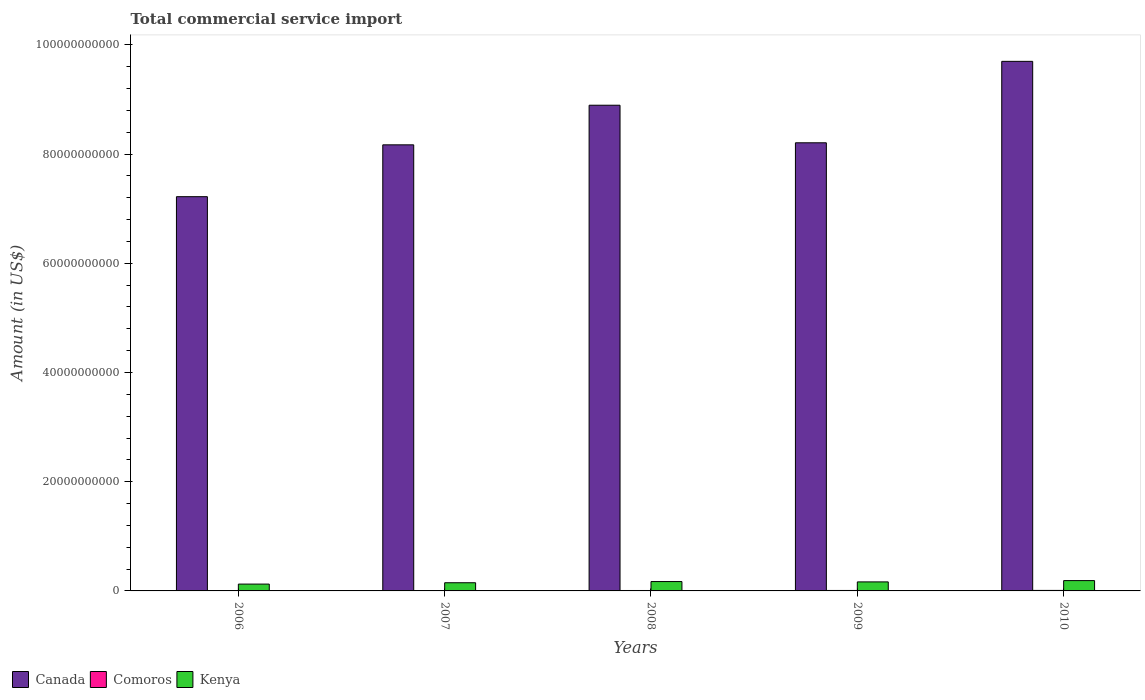How many different coloured bars are there?
Offer a terse response. 3. What is the label of the 3rd group of bars from the left?
Your answer should be very brief. 2008. In how many cases, is the number of bars for a given year not equal to the number of legend labels?
Provide a short and direct response. 0. What is the total commercial service import in Canada in 2008?
Your answer should be compact. 8.90e+1. Across all years, what is the maximum total commercial service import in Comoros?
Make the answer very short. 9.30e+07. Across all years, what is the minimum total commercial service import in Kenya?
Make the answer very short. 1.25e+09. What is the total total commercial service import in Comoros in the graph?
Your answer should be very brief. 3.70e+08. What is the difference between the total commercial service import in Canada in 2006 and that in 2008?
Your response must be concise. -1.67e+1. What is the difference between the total commercial service import in Comoros in 2010 and the total commercial service import in Canada in 2006?
Give a very brief answer. -7.21e+1. What is the average total commercial service import in Kenya per year?
Keep it short and to the point. 1.60e+09. In the year 2007, what is the difference between the total commercial service import in Canada and total commercial service import in Comoros?
Your answer should be very brief. 8.16e+1. In how many years, is the total commercial service import in Kenya greater than 36000000000 US$?
Provide a short and direct response. 0. What is the ratio of the total commercial service import in Comoros in 2007 to that in 2008?
Your answer should be compact. 0.81. Is the total commercial service import in Canada in 2006 less than that in 2010?
Provide a succinct answer. Yes. What is the difference between the highest and the second highest total commercial service import in Canada?
Provide a succinct answer. 8.03e+09. What is the difference between the highest and the lowest total commercial service import in Kenya?
Your answer should be compact. 6.38e+08. In how many years, is the total commercial service import in Kenya greater than the average total commercial service import in Kenya taken over all years?
Give a very brief answer. 3. What does the 3rd bar from the left in 2010 represents?
Offer a terse response. Kenya. What does the 2nd bar from the right in 2009 represents?
Ensure brevity in your answer.  Comoros. Is it the case that in every year, the sum of the total commercial service import in Kenya and total commercial service import in Canada is greater than the total commercial service import in Comoros?
Give a very brief answer. Yes. Are all the bars in the graph horizontal?
Your answer should be very brief. No. What is the difference between two consecutive major ticks on the Y-axis?
Provide a short and direct response. 2.00e+1. Are the values on the major ticks of Y-axis written in scientific E-notation?
Keep it short and to the point. No. Does the graph contain any zero values?
Your response must be concise. No. Does the graph contain grids?
Offer a very short reply. No. How are the legend labels stacked?
Make the answer very short. Horizontal. What is the title of the graph?
Provide a short and direct response. Total commercial service import. Does "Lebanon" appear as one of the legend labels in the graph?
Give a very brief answer. No. What is the label or title of the X-axis?
Your response must be concise. Years. What is the label or title of the Y-axis?
Provide a short and direct response. Amount (in US$). What is the Amount (in US$) of Canada in 2006?
Your response must be concise. 7.22e+1. What is the Amount (in US$) in Comoros in 2006?
Provide a short and direct response. 5.40e+07. What is the Amount (in US$) in Kenya in 2006?
Give a very brief answer. 1.25e+09. What is the Amount (in US$) of Canada in 2007?
Your response must be concise. 8.17e+1. What is the Amount (in US$) in Comoros in 2007?
Give a very brief answer. 6.23e+07. What is the Amount (in US$) in Kenya in 2007?
Give a very brief answer. 1.50e+09. What is the Amount (in US$) in Canada in 2008?
Ensure brevity in your answer.  8.90e+1. What is the Amount (in US$) of Comoros in 2008?
Give a very brief answer. 7.72e+07. What is the Amount (in US$) of Kenya in 2008?
Offer a very short reply. 1.72e+09. What is the Amount (in US$) of Canada in 2009?
Your answer should be compact. 8.21e+1. What is the Amount (in US$) of Comoros in 2009?
Ensure brevity in your answer.  8.35e+07. What is the Amount (in US$) of Kenya in 2009?
Give a very brief answer. 1.65e+09. What is the Amount (in US$) of Canada in 2010?
Make the answer very short. 9.70e+1. What is the Amount (in US$) of Comoros in 2010?
Make the answer very short. 9.30e+07. What is the Amount (in US$) of Kenya in 2010?
Make the answer very short. 1.89e+09. Across all years, what is the maximum Amount (in US$) of Canada?
Offer a very short reply. 9.70e+1. Across all years, what is the maximum Amount (in US$) in Comoros?
Make the answer very short. 9.30e+07. Across all years, what is the maximum Amount (in US$) of Kenya?
Provide a succinct answer. 1.89e+09. Across all years, what is the minimum Amount (in US$) in Canada?
Your answer should be compact. 7.22e+1. Across all years, what is the minimum Amount (in US$) of Comoros?
Your answer should be compact. 5.40e+07. Across all years, what is the minimum Amount (in US$) of Kenya?
Provide a short and direct response. 1.25e+09. What is the total Amount (in US$) of Canada in the graph?
Offer a terse response. 4.22e+11. What is the total Amount (in US$) of Comoros in the graph?
Your answer should be very brief. 3.70e+08. What is the total Amount (in US$) in Kenya in the graph?
Provide a succinct answer. 8.01e+09. What is the difference between the Amount (in US$) in Canada in 2006 and that in 2007?
Your response must be concise. -9.50e+09. What is the difference between the Amount (in US$) in Comoros in 2006 and that in 2007?
Your response must be concise. -8.35e+06. What is the difference between the Amount (in US$) of Kenya in 2006 and that in 2007?
Give a very brief answer. -2.47e+08. What is the difference between the Amount (in US$) in Canada in 2006 and that in 2008?
Keep it short and to the point. -1.67e+1. What is the difference between the Amount (in US$) of Comoros in 2006 and that in 2008?
Provide a short and direct response. -2.32e+07. What is the difference between the Amount (in US$) of Kenya in 2006 and that in 2008?
Provide a short and direct response. -4.64e+08. What is the difference between the Amount (in US$) in Canada in 2006 and that in 2009?
Ensure brevity in your answer.  -9.87e+09. What is the difference between the Amount (in US$) of Comoros in 2006 and that in 2009?
Offer a very short reply. -2.95e+07. What is the difference between the Amount (in US$) of Kenya in 2006 and that in 2009?
Your answer should be very brief. -4.00e+08. What is the difference between the Amount (in US$) in Canada in 2006 and that in 2010?
Ensure brevity in your answer.  -2.48e+1. What is the difference between the Amount (in US$) in Comoros in 2006 and that in 2010?
Your response must be concise. -3.90e+07. What is the difference between the Amount (in US$) in Kenya in 2006 and that in 2010?
Your answer should be compact. -6.38e+08. What is the difference between the Amount (in US$) in Canada in 2007 and that in 2008?
Make the answer very short. -7.25e+09. What is the difference between the Amount (in US$) of Comoros in 2007 and that in 2008?
Your answer should be compact. -1.49e+07. What is the difference between the Amount (in US$) in Kenya in 2007 and that in 2008?
Offer a very short reply. -2.18e+08. What is the difference between the Amount (in US$) in Canada in 2007 and that in 2009?
Keep it short and to the point. -3.74e+08. What is the difference between the Amount (in US$) of Comoros in 2007 and that in 2009?
Provide a short and direct response. -2.12e+07. What is the difference between the Amount (in US$) in Kenya in 2007 and that in 2009?
Your answer should be compact. -1.54e+08. What is the difference between the Amount (in US$) of Canada in 2007 and that in 2010?
Your answer should be very brief. -1.53e+1. What is the difference between the Amount (in US$) in Comoros in 2007 and that in 2010?
Offer a very short reply. -3.06e+07. What is the difference between the Amount (in US$) of Kenya in 2007 and that in 2010?
Offer a very short reply. -3.91e+08. What is the difference between the Amount (in US$) in Canada in 2008 and that in 2009?
Make the answer very short. 6.88e+09. What is the difference between the Amount (in US$) of Comoros in 2008 and that in 2009?
Provide a succinct answer. -6.31e+06. What is the difference between the Amount (in US$) in Kenya in 2008 and that in 2009?
Your answer should be very brief. 6.37e+07. What is the difference between the Amount (in US$) in Canada in 2008 and that in 2010?
Keep it short and to the point. -8.03e+09. What is the difference between the Amount (in US$) in Comoros in 2008 and that in 2010?
Your answer should be very brief. -1.58e+07. What is the difference between the Amount (in US$) of Kenya in 2008 and that in 2010?
Keep it short and to the point. -1.74e+08. What is the difference between the Amount (in US$) of Canada in 2009 and that in 2010?
Your answer should be compact. -1.49e+1. What is the difference between the Amount (in US$) of Comoros in 2009 and that in 2010?
Provide a succinct answer. -9.48e+06. What is the difference between the Amount (in US$) of Kenya in 2009 and that in 2010?
Offer a terse response. -2.37e+08. What is the difference between the Amount (in US$) in Canada in 2006 and the Amount (in US$) in Comoros in 2007?
Offer a terse response. 7.21e+1. What is the difference between the Amount (in US$) in Canada in 2006 and the Amount (in US$) in Kenya in 2007?
Offer a very short reply. 7.07e+1. What is the difference between the Amount (in US$) of Comoros in 2006 and the Amount (in US$) of Kenya in 2007?
Your response must be concise. -1.44e+09. What is the difference between the Amount (in US$) in Canada in 2006 and the Amount (in US$) in Comoros in 2008?
Provide a short and direct response. 7.21e+1. What is the difference between the Amount (in US$) of Canada in 2006 and the Amount (in US$) of Kenya in 2008?
Provide a succinct answer. 7.05e+1. What is the difference between the Amount (in US$) of Comoros in 2006 and the Amount (in US$) of Kenya in 2008?
Ensure brevity in your answer.  -1.66e+09. What is the difference between the Amount (in US$) of Canada in 2006 and the Amount (in US$) of Comoros in 2009?
Ensure brevity in your answer.  7.21e+1. What is the difference between the Amount (in US$) of Canada in 2006 and the Amount (in US$) of Kenya in 2009?
Provide a short and direct response. 7.05e+1. What is the difference between the Amount (in US$) in Comoros in 2006 and the Amount (in US$) in Kenya in 2009?
Your answer should be very brief. -1.60e+09. What is the difference between the Amount (in US$) in Canada in 2006 and the Amount (in US$) in Comoros in 2010?
Provide a succinct answer. 7.21e+1. What is the difference between the Amount (in US$) in Canada in 2006 and the Amount (in US$) in Kenya in 2010?
Give a very brief answer. 7.03e+1. What is the difference between the Amount (in US$) in Comoros in 2006 and the Amount (in US$) in Kenya in 2010?
Your answer should be compact. -1.84e+09. What is the difference between the Amount (in US$) of Canada in 2007 and the Amount (in US$) of Comoros in 2008?
Make the answer very short. 8.16e+1. What is the difference between the Amount (in US$) in Canada in 2007 and the Amount (in US$) in Kenya in 2008?
Offer a very short reply. 8.00e+1. What is the difference between the Amount (in US$) in Comoros in 2007 and the Amount (in US$) in Kenya in 2008?
Ensure brevity in your answer.  -1.65e+09. What is the difference between the Amount (in US$) in Canada in 2007 and the Amount (in US$) in Comoros in 2009?
Offer a very short reply. 8.16e+1. What is the difference between the Amount (in US$) in Canada in 2007 and the Amount (in US$) in Kenya in 2009?
Your response must be concise. 8.00e+1. What is the difference between the Amount (in US$) of Comoros in 2007 and the Amount (in US$) of Kenya in 2009?
Offer a very short reply. -1.59e+09. What is the difference between the Amount (in US$) of Canada in 2007 and the Amount (in US$) of Comoros in 2010?
Offer a very short reply. 8.16e+1. What is the difference between the Amount (in US$) in Canada in 2007 and the Amount (in US$) in Kenya in 2010?
Offer a terse response. 7.98e+1. What is the difference between the Amount (in US$) in Comoros in 2007 and the Amount (in US$) in Kenya in 2010?
Offer a very short reply. -1.83e+09. What is the difference between the Amount (in US$) in Canada in 2008 and the Amount (in US$) in Comoros in 2009?
Ensure brevity in your answer.  8.89e+1. What is the difference between the Amount (in US$) of Canada in 2008 and the Amount (in US$) of Kenya in 2009?
Provide a short and direct response. 8.73e+1. What is the difference between the Amount (in US$) of Comoros in 2008 and the Amount (in US$) of Kenya in 2009?
Provide a succinct answer. -1.58e+09. What is the difference between the Amount (in US$) of Canada in 2008 and the Amount (in US$) of Comoros in 2010?
Your response must be concise. 8.89e+1. What is the difference between the Amount (in US$) of Canada in 2008 and the Amount (in US$) of Kenya in 2010?
Make the answer very short. 8.71e+1. What is the difference between the Amount (in US$) in Comoros in 2008 and the Amount (in US$) in Kenya in 2010?
Offer a terse response. -1.81e+09. What is the difference between the Amount (in US$) in Canada in 2009 and the Amount (in US$) in Comoros in 2010?
Provide a succinct answer. 8.20e+1. What is the difference between the Amount (in US$) in Canada in 2009 and the Amount (in US$) in Kenya in 2010?
Your response must be concise. 8.02e+1. What is the difference between the Amount (in US$) of Comoros in 2009 and the Amount (in US$) of Kenya in 2010?
Offer a very short reply. -1.81e+09. What is the average Amount (in US$) of Canada per year?
Your answer should be compact. 8.44e+1. What is the average Amount (in US$) of Comoros per year?
Provide a short and direct response. 7.40e+07. What is the average Amount (in US$) of Kenya per year?
Your answer should be compact. 1.60e+09. In the year 2006, what is the difference between the Amount (in US$) of Canada and Amount (in US$) of Comoros?
Provide a short and direct response. 7.21e+1. In the year 2006, what is the difference between the Amount (in US$) in Canada and Amount (in US$) in Kenya?
Offer a very short reply. 7.09e+1. In the year 2006, what is the difference between the Amount (in US$) in Comoros and Amount (in US$) in Kenya?
Your answer should be compact. -1.20e+09. In the year 2007, what is the difference between the Amount (in US$) in Canada and Amount (in US$) in Comoros?
Your answer should be very brief. 8.16e+1. In the year 2007, what is the difference between the Amount (in US$) of Canada and Amount (in US$) of Kenya?
Your answer should be compact. 8.02e+1. In the year 2007, what is the difference between the Amount (in US$) in Comoros and Amount (in US$) in Kenya?
Offer a terse response. -1.44e+09. In the year 2008, what is the difference between the Amount (in US$) in Canada and Amount (in US$) in Comoros?
Provide a short and direct response. 8.89e+1. In the year 2008, what is the difference between the Amount (in US$) of Canada and Amount (in US$) of Kenya?
Offer a terse response. 8.72e+1. In the year 2008, what is the difference between the Amount (in US$) of Comoros and Amount (in US$) of Kenya?
Make the answer very short. -1.64e+09. In the year 2009, what is the difference between the Amount (in US$) in Canada and Amount (in US$) in Comoros?
Ensure brevity in your answer.  8.20e+1. In the year 2009, what is the difference between the Amount (in US$) of Canada and Amount (in US$) of Kenya?
Keep it short and to the point. 8.04e+1. In the year 2009, what is the difference between the Amount (in US$) in Comoros and Amount (in US$) in Kenya?
Offer a terse response. -1.57e+09. In the year 2010, what is the difference between the Amount (in US$) of Canada and Amount (in US$) of Comoros?
Provide a succinct answer. 9.69e+1. In the year 2010, what is the difference between the Amount (in US$) in Canada and Amount (in US$) in Kenya?
Offer a very short reply. 9.51e+1. In the year 2010, what is the difference between the Amount (in US$) of Comoros and Amount (in US$) of Kenya?
Keep it short and to the point. -1.80e+09. What is the ratio of the Amount (in US$) of Canada in 2006 to that in 2007?
Your response must be concise. 0.88. What is the ratio of the Amount (in US$) in Comoros in 2006 to that in 2007?
Keep it short and to the point. 0.87. What is the ratio of the Amount (in US$) of Kenya in 2006 to that in 2007?
Offer a very short reply. 0.84. What is the ratio of the Amount (in US$) of Canada in 2006 to that in 2008?
Provide a short and direct response. 0.81. What is the ratio of the Amount (in US$) of Comoros in 2006 to that in 2008?
Your answer should be very brief. 0.7. What is the ratio of the Amount (in US$) of Kenya in 2006 to that in 2008?
Provide a short and direct response. 0.73. What is the ratio of the Amount (in US$) of Canada in 2006 to that in 2009?
Ensure brevity in your answer.  0.88. What is the ratio of the Amount (in US$) in Comoros in 2006 to that in 2009?
Offer a very short reply. 0.65. What is the ratio of the Amount (in US$) in Kenya in 2006 to that in 2009?
Give a very brief answer. 0.76. What is the ratio of the Amount (in US$) of Canada in 2006 to that in 2010?
Provide a succinct answer. 0.74. What is the ratio of the Amount (in US$) of Comoros in 2006 to that in 2010?
Offer a very short reply. 0.58. What is the ratio of the Amount (in US$) in Kenya in 2006 to that in 2010?
Provide a succinct answer. 0.66. What is the ratio of the Amount (in US$) of Canada in 2007 to that in 2008?
Ensure brevity in your answer.  0.92. What is the ratio of the Amount (in US$) in Comoros in 2007 to that in 2008?
Keep it short and to the point. 0.81. What is the ratio of the Amount (in US$) in Kenya in 2007 to that in 2008?
Give a very brief answer. 0.87. What is the ratio of the Amount (in US$) in Comoros in 2007 to that in 2009?
Give a very brief answer. 0.75. What is the ratio of the Amount (in US$) in Kenya in 2007 to that in 2009?
Offer a very short reply. 0.91. What is the ratio of the Amount (in US$) of Canada in 2007 to that in 2010?
Provide a succinct answer. 0.84. What is the ratio of the Amount (in US$) in Comoros in 2007 to that in 2010?
Provide a succinct answer. 0.67. What is the ratio of the Amount (in US$) in Kenya in 2007 to that in 2010?
Make the answer very short. 0.79. What is the ratio of the Amount (in US$) of Canada in 2008 to that in 2009?
Your response must be concise. 1.08. What is the ratio of the Amount (in US$) in Comoros in 2008 to that in 2009?
Your response must be concise. 0.92. What is the ratio of the Amount (in US$) of Kenya in 2008 to that in 2009?
Provide a succinct answer. 1.04. What is the ratio of the Amount (in US$) of Canada in 2008 to that in 2010?
Offer a very short reply. 0.92. What is the ratio of the Amount (in US$) of Comoros in 2008 to that in 2010?
Give a very brief answer. 0.83. What is the ratio of the Amount (in US$) of Kenya in 2008 to that in 2010?
Give a very brief answer. 0.91. What is the ratio of the Amount (in US$) in Canada in 2009 to that in 2010?
Your response must be concise. 0.85. What is the ratio of the Amount (in US$) of Comoros in 2009 to that in 2010?
Provide a short and direct response. 0.9. What is the ratio of the Amount (in US$) in Kenya in 2009 to that in 2010?
Give a very brief answer. 0.87. What is the difference between the highest and the second highest Amount (in US$) in Canada?
Give a very brief answer. 8.03e+09. What is the difference between the highest and the second highest Amount (in US$) in Comoros?
Your answer should be very brief. 9.48e+06. What is the difference between the highest and the second highest Amount (in US$) of Kenya?
Give a very brief answer. 1.74e+08. What is the difference between the highest and the lowest Amount (in US$) of Canada?
Keep it short and to the point. 2.48e+1. What is the difference between the highest and the lowest Amount (in US$) of Comoros?
Give a very brief answer. 3.90e+07. What is the difference between the highest and the lowest Amount (in US$) of Kenya?
Provide a short and direct response. 6.38e+08. 